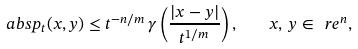<formula> <loc_0><loc_0><loc_500><loc_500>\ a b s { p _ { t } ( x , y ) } \leq t ^ { - n / m } \, \gamma \left ( \frac { | x - y | } { t ^ { 1 / m } } \right ) , \quad x , \, y \in \ r e ^ { n } ,</formula> 